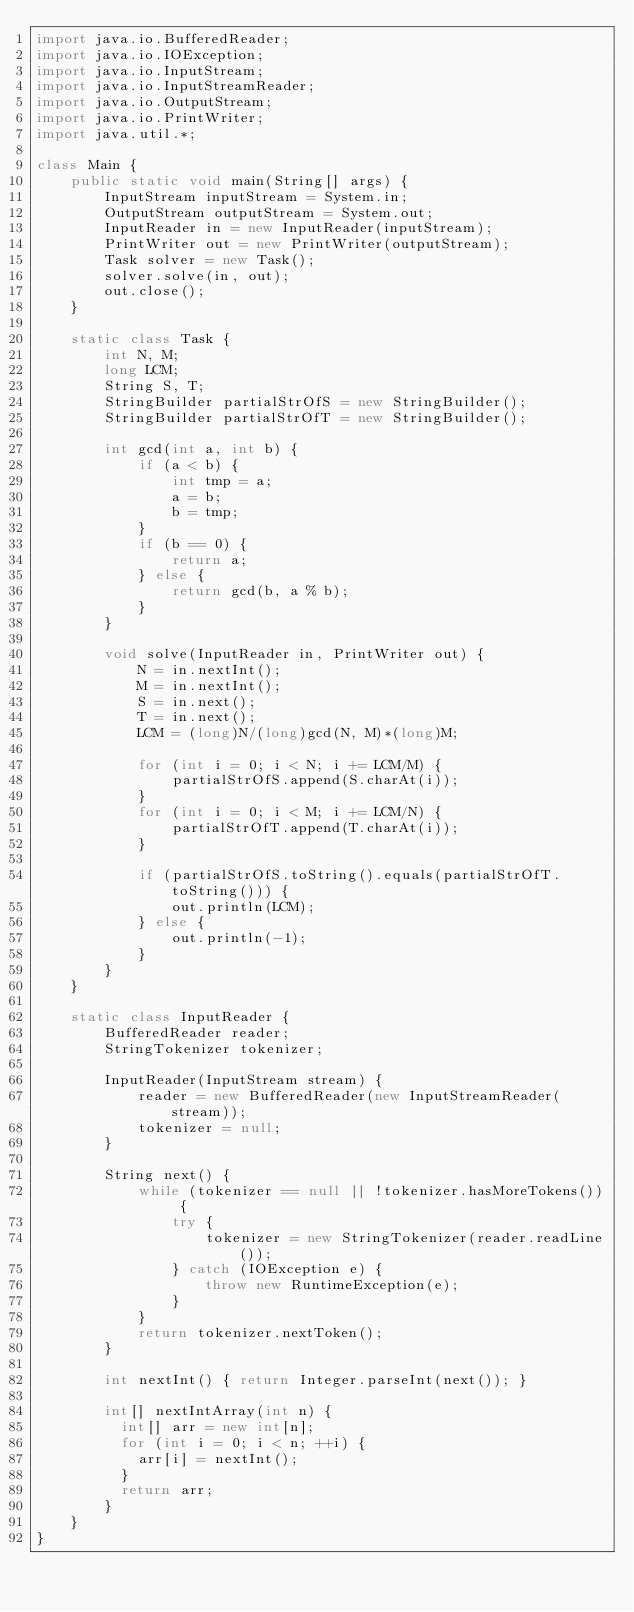<code> <loc_0><loc_0><loc_500><loc_500><_Java_>import java.io.BufferedReader;
import java.io.IOException;
import java.io.InputStream;
import java.io.InputStreamReader;
import java.io.OutputStream;
import java.io.PrintWriter;
import java.util.*;

class Main {
    public static void main(String[] args) {
        InputStream inputStream = System.in;
        OutputStream outputStream = System.out;
        InputReader in = new InputReader(inputStream);
        PrintWriter out = new PrintWriter(outputStream);
        Task solver = new Task();
        solver.solve(in, out);
        out.close();
    }

    static class Task {
        int N, M;
        long LCM;
        String S, T;
        StringBuilder partialStrOfS = new StringBuilder();
        StringBuilder partialStrOfT = new StringBuilder();

        int gcd(int a, int b) {
            if (a < b) {
                int tmp = a;
                a = b;
                b = tmp;
            }
            if (b == 0) {
                return a;
            } else {
                return gcd(b, a % b);
            }
        }

        void solve(InputReader in, PrintWriter out) {
            N = in.nextInt();
            M = in.nextInt();
            S = in.next();
            T = in.next();
            LCM = (long)N/(long)gcd(N, M)*(long)M;

            for (int i = 0; i < N; i += LCM/M) {
                partialStrOfS.append(S.charAt(i));
            }
            for (int i = 0; i < M; i += LCM/N) {
                partialStrOfT.append(T.charAt(i));
            }

            if (partialStrOfS.toString().equals(partialStrOfT.toString())) {
                out.println(LCM);
            } else {
                out.println(-1);
            }
        }
    }

    static class InputReader {
        BufferedReader reader;
        StringTokenizer tokenizer;

        InputReader(InputStream stream) {
            reader = new BufferedReader(new InputStreamReader(stream));
            tokenizer = null;
        }

        String next() {
            while (tokenizer == null || !tokenizer.hasMoreTokens()) {
                try {
                    tokenizer = new StringTokenizer(reader.readLine());
                } catch (IOException e) {
                    throw new RuntimeException(e);
                }
            }
            return tokenizer.nextToken();
        }

        int nextInt() { return Integer.parseInt(next()); }

        int[] nextIntArray(int n) {
        	int[] arr = new int[n];
        	for (int i = 0; i < n; ++i) {
        		arr[i] = nextInt();
        	}
        	return arr;
        }
    }
}
</code> 